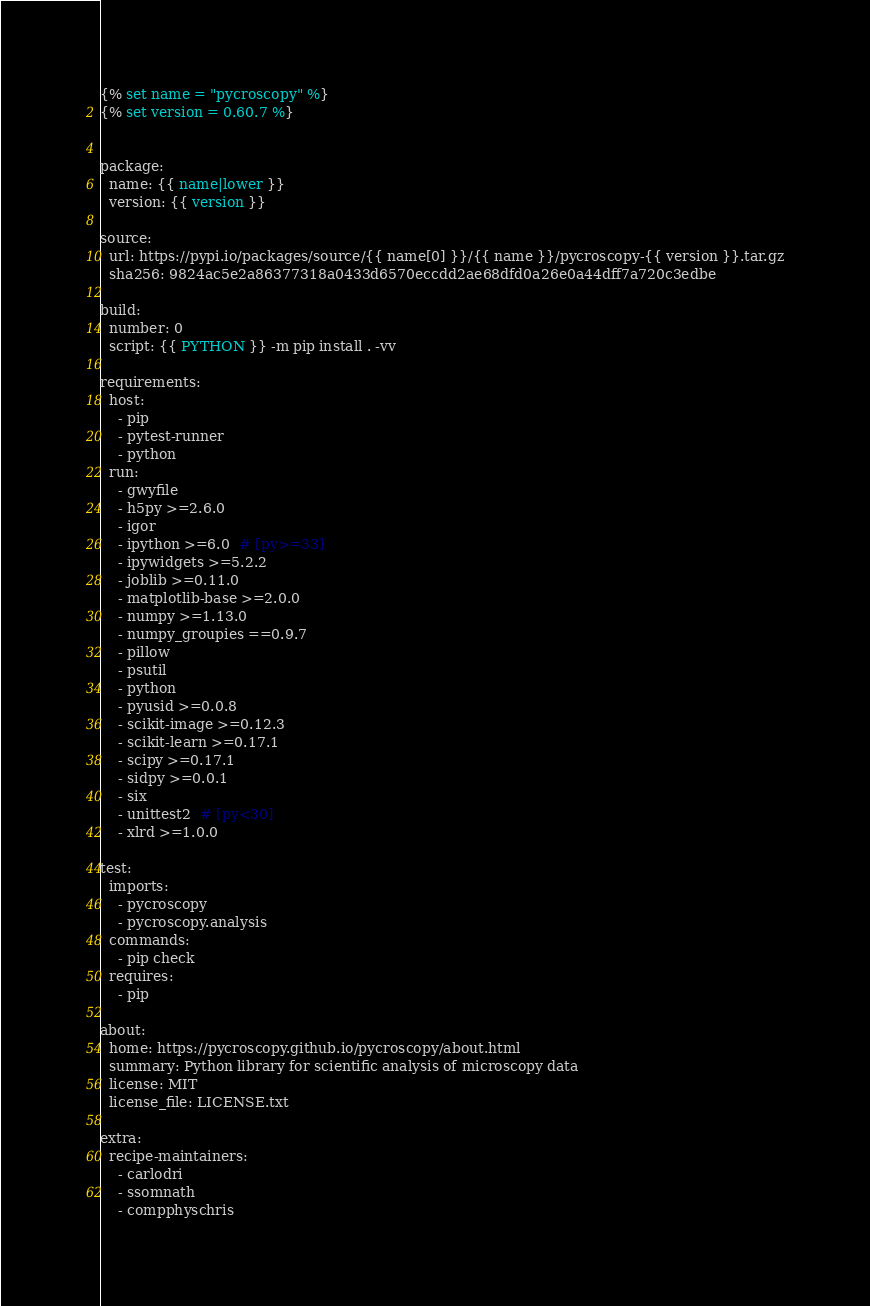Convert code to text. <code><loc_0><loc_0><loc_500><loc_500><_YAML_>{% set name = "pycroscopy" %}
{% set version = 0.60.7 %}


package:
  name: {{ name|lower }}
  version: {{ version }}

source:
  url: https://pypi.io/packages/source/{{ name[0] }}/{{ name }}/pycroscopy-{{ version }}.tar.gz
  sha256: 9824ac5e2a86377318a0433d6570eccdd2ae68dfd0a26e0a44dff7a720c3edbe

build:
  number: 0
  script: {{ PYTHON }} -m pip install . -vv

requirements:
  host:
    - pip
    - pytest-runner
    - python
  run:
    - gwyfile
    - h5py >=2.6.0
    - igor
    - ipython >=6.0  # [py>=33]
    - ipywidgets >=5.2.2
    - joblib >=0.11.0
    - matplotlib-base >=2.0.0
    - numpy >=1.13.0
    - numpy_groupies ==0.9.7
    - pillow
    - psutil
    - python
    - pyusid >=0.0.8
    - scikit-image >=0.12.3
    - scikit-learn >=0.17.1
    - scipy >=0.17.1
    - sidpy >=0.0.1
    - six
    - unittest2  # [py<30]
    - xlrd >=1.0.0

test:
  imports:
    - pycroscopy
    - pycroscopy.analysis
  commands:
    - pip check
  requires:
    - pip

about:
  home: https://pycroscopy.github.io/pycroscopy/about.html
  summary: Python library for scientific analysis of microscopy data
  license: MIT
  license_file: LICENSE.txt

extra:
  recipe-maintainers:
    - carlodri
    - ssomnath
    - compphyschris
</code> 